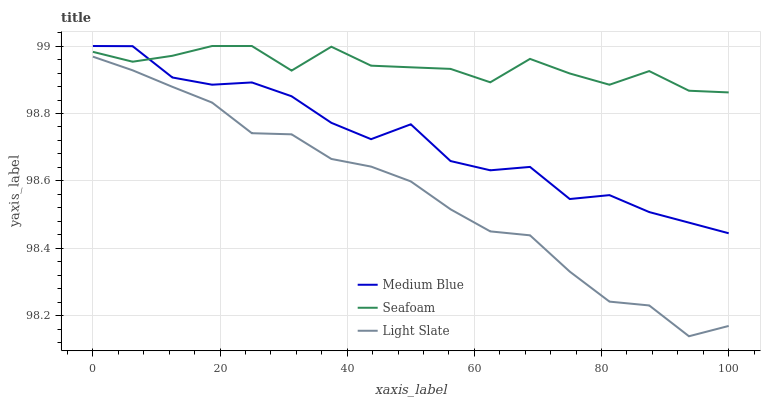Does Medium Blue have the minimum area under the curve?
Answer yes or no. No. Does Medium Blue have the maximum area under the curve?
Answer yes or no. No. Is Medium Blue the smoothest?
Answer yes or no. No. Is Medium Blue the roughest?
Answer yes or no. No. Does Medium Blue have the lowest value?
Answer yes or no. No. Is Light Slate less than Medium Blue?
Answer yes or no. Yes. Is Medium Blue greater than Light Slate?
Answer yes or no. Yes. Does Light Slate intersect Medium Blue?
Answer yes or no. No. 